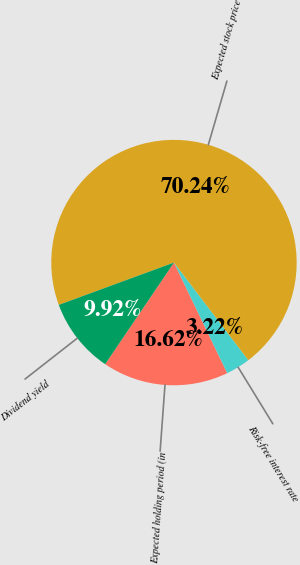Convert chart. <chart><loc_0><loc_0><loc_500><loc_500><pie_chart><fcel>Expected holding period (in<fcel>Risk-free interest rate<fcel>Expected stock price<fcel>Dividend yield<nl><fcel>16.62%<fcel>3.22%<fcel>70.24%<fcel>9.92%<nl></chart> 